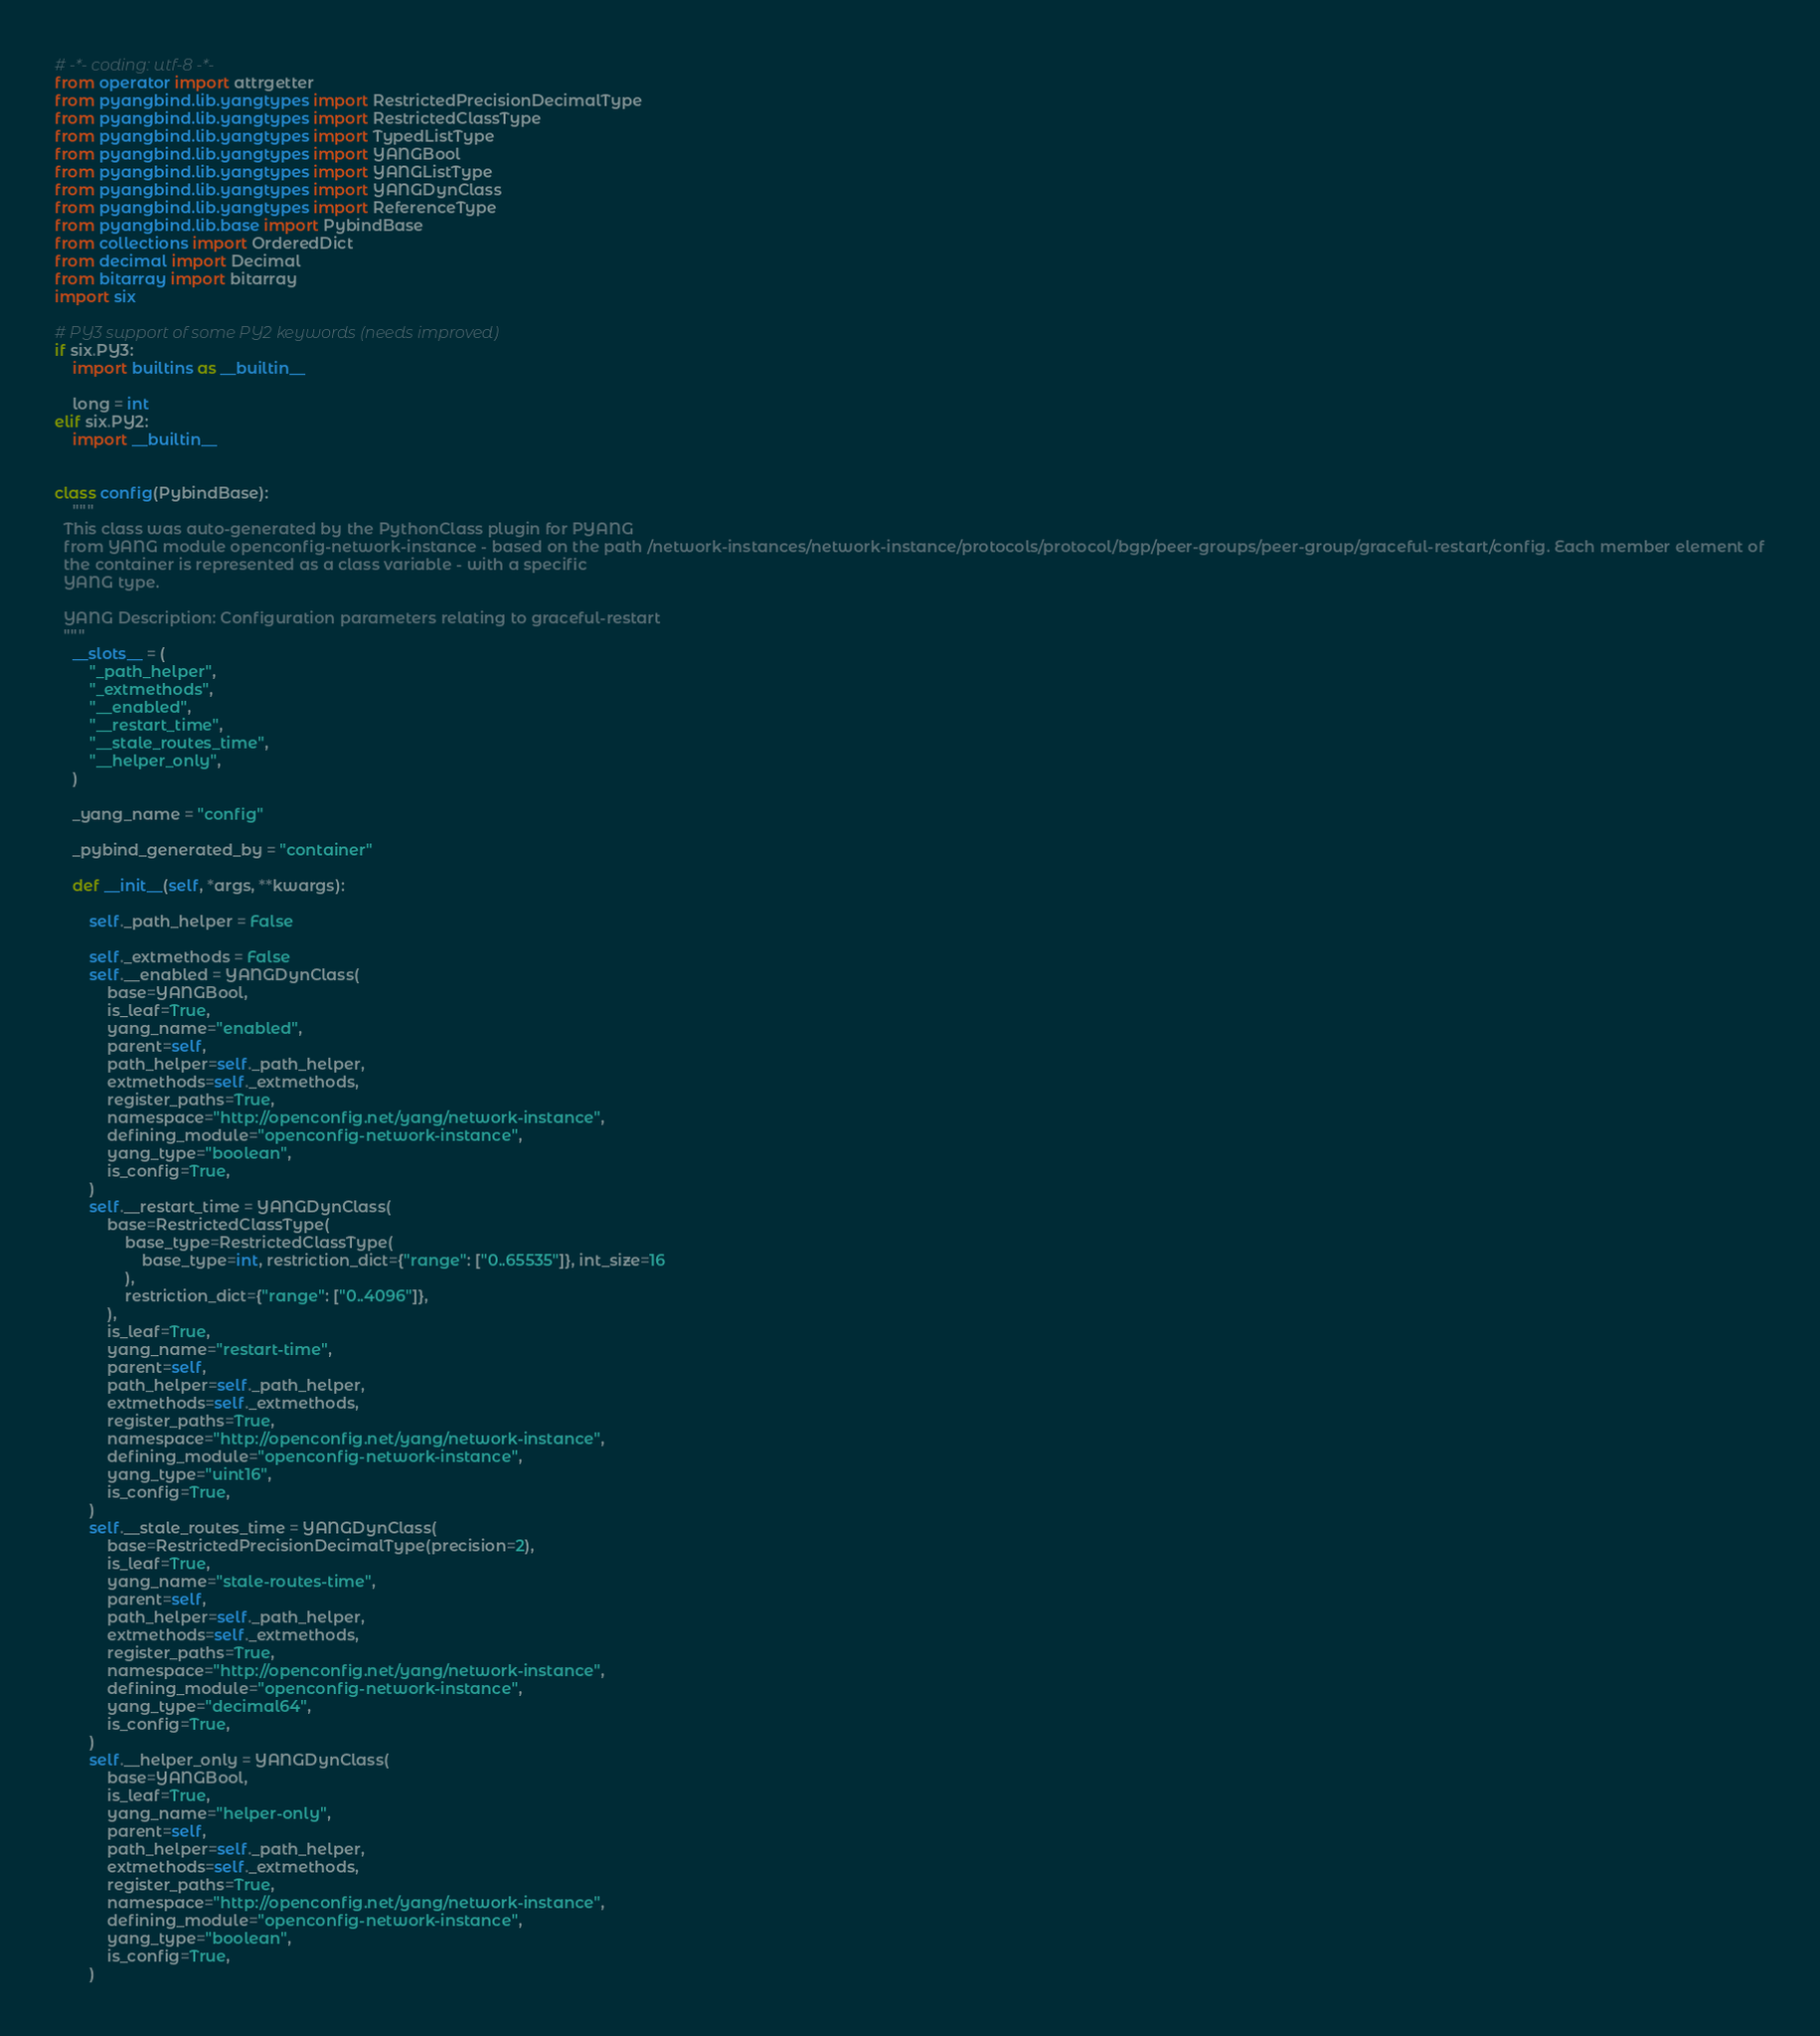<code> <loc_0><loc_0><loc_500><loc_500><_Python_># -*- coding: utf-8 -*-
from operator import attrgetter
from pyangbind.lib.yangtypes import RestrictedPrecisionDecimalType
from pyangbind.lib.yangtypes import RestrictedClassType
from pyangbind.lib.yangtypes import TypedListType
from pyangbind.lib.yangtypes import YANGBool
from pyangbind.lib.yangtypes import YANGListType
from pyangbind.lib.yangtypes import YANGDynClass
from pyangbind.lib.yangtypes import ReferenceType
from pyangbind.lib.base import PybindBase
from collections import OrderedDict
from decimal import Decimal
from bitarray import bitarray
import six

# PY3 support of some PY2 keywords (needs improved)
if six.PY3:
    import builtins as __builtin__

    long = int
elif six.PY2:
    import __builtin__


class config(PybindBase):
    """
  This class was auto-generated by the PythonClass plugin for PYANG
  from YANG module openconfig-network-instance - based on the path /network-instances/network-instance/protocols/protocol/bgp/peer-groups/peer-group/graceful-restart/config. Each member element of
  the container is represented as a class variable - with a specific
  YANG type.

  YANG Description: Configuration parameters relating to graceful-restart
  """
    __slots__ = (
        "_path_helper",
        "_extmethods",
        "__enabled",
        "__restart_time",
        "__stale_routes_time",
        "__helper_only",
    )

    _yang_name = "config"

    _pybind_generated_by = "container"

    def __init__(self, *args, **kwargs):

        self._path_helper = False

        self._extmethods = False
        self.__enabled = YANGDynClass(
            base=YANGBool,
            is_leaf=True,
            yang_name="enabled",
            parent=self,
            path_helper=self._path_helper,
            extmethods=self._extmethods,
            register_paths=True,
            namespace="http://openconfig.net/yang/network-instance",
            defining_module="openconfig-network-instance",
            yang_type="boolean",
            is_config=True,
        )
        self.__restart_time = YANGDynClass(
            base=RestrictedClassType(
                base_type=RestrictedClassType(
                    base_type=int, restriction_dict={"range": ["0..65535"]}, int_size=16
                ),
                restriction_dict={"range": ["0..4096"]},
            ),
            is_leaf=True,
            yang_name="restart-time",
            parent=self,
            path_helper=self._path_helper,
            extmethods=self._extmethods,
            register_paths=True,
            namespace="http://openconfig.net/yang/network-instance",
            defining_module="openconfig-network-instance",
            yang_type="uint16",
            is_config=True,
        )
        self.__stale_routes_time = YANGDynClass(
            base=RestrictedPrecisionDecimalType(precision=2),
            is_leaf=True,
            yang_name="stale-routes-time",
            parent=self,
            path_helper=self._path_helper,
            extmethods=self._extmethods,
            register_paths=True,
            namespace="http://openconfig.net/yang/network-instance",
            defining_module="openconfig-network-instance",
            yang_type="decimal64",
            is_config=True,
        )
        self.__helper_only = YANGDynClass(
            base=YANGBool,
            is_leaf=True,
            yang_name="helper-only",
            parent=self,
            path_helper=self._path_helper,
            extmethods=self._extmethods,
            register_paths=True,
            namespace="http://openconfig.net/yang/network-instance",
            defining_module="openconfig-network-instance",
            yang_type="boolean",
            is_config=True,
        )
</code> 